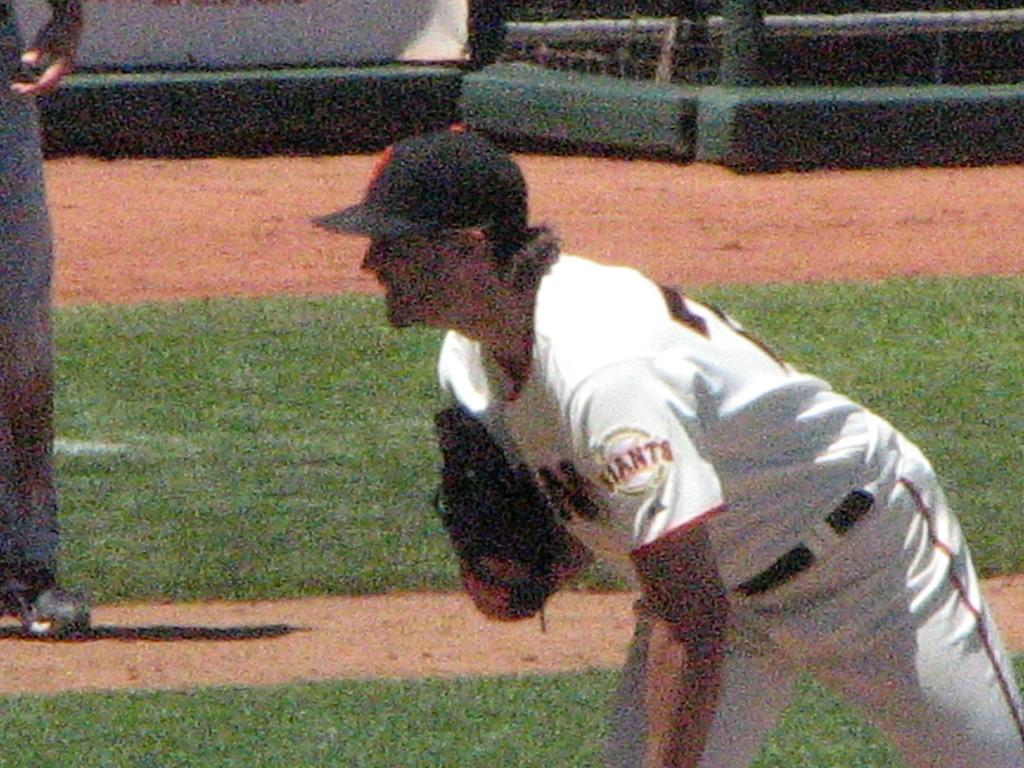<image>
Create a compact narrative representing the image presented. a Giants player is looking in for a sign 